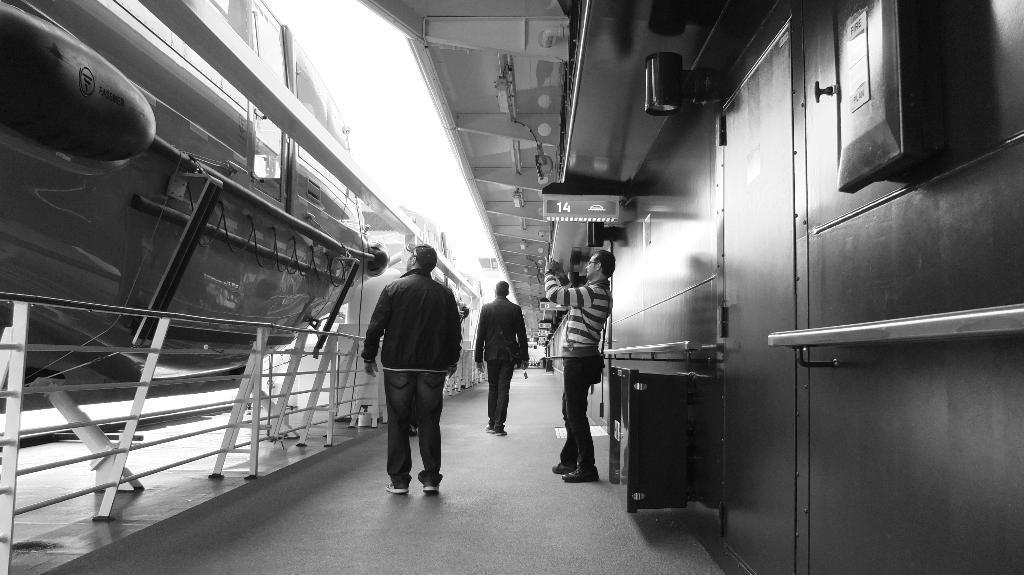Describe this image in one or two sentences. In this image there are three personś , the first person is standing,other person is walking ,and the third person is taking photograph,there is ship, there is a board with 14 number on it. 